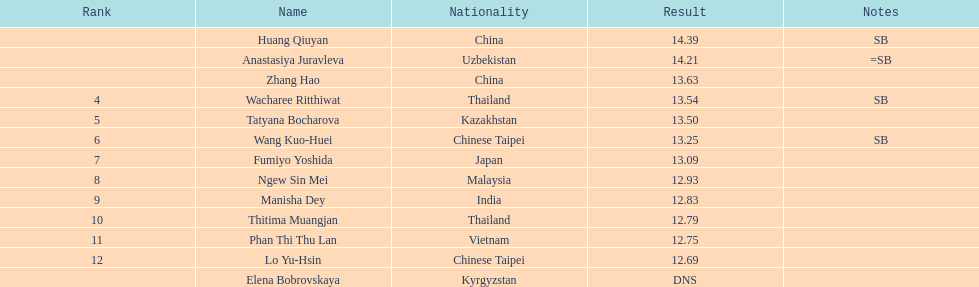The woman who took first place belonged to which nationality? China. 